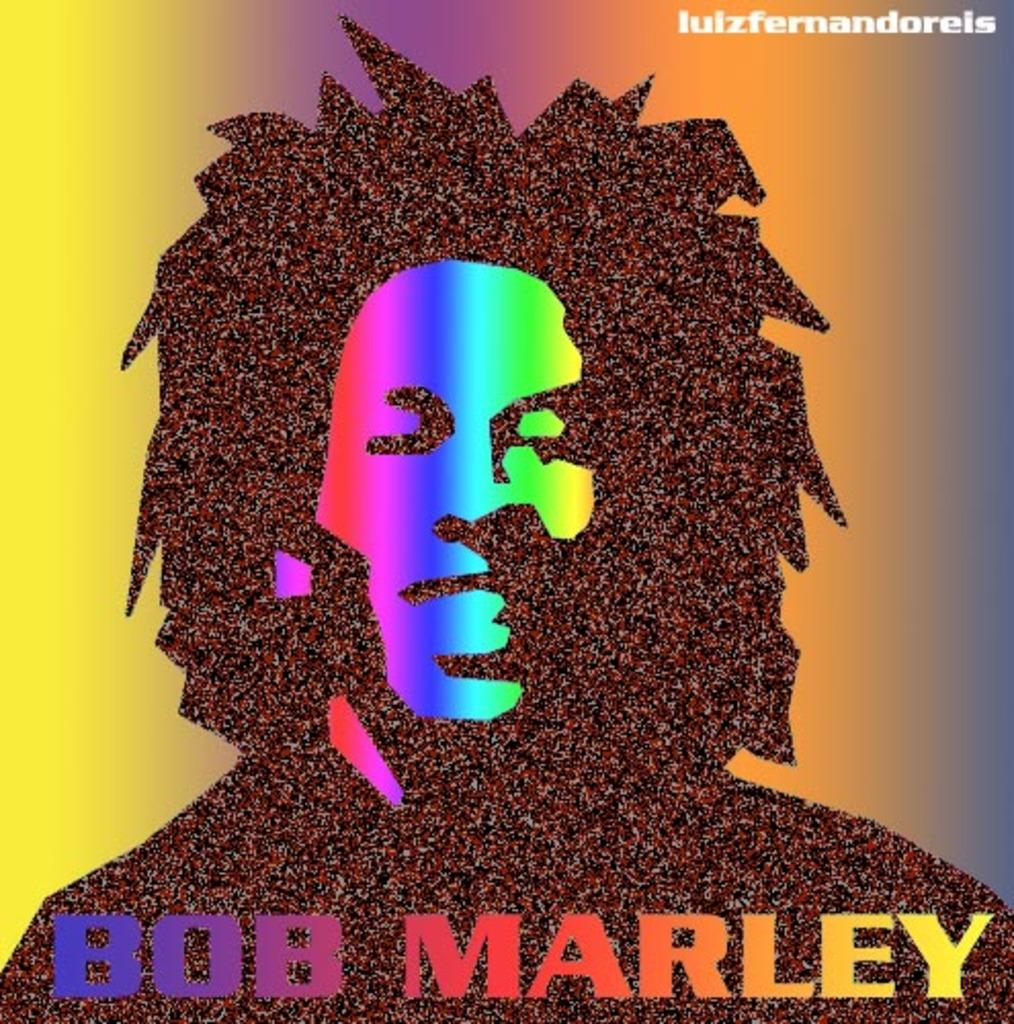<image>
Render a clear and concise summary of the photo. A very colorful Bob Marley album with a bunch of grain and cool specks 